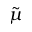<formula> <loc_0><loc_0><loc_500><loc_500>\tilde { \mu }</formula> 